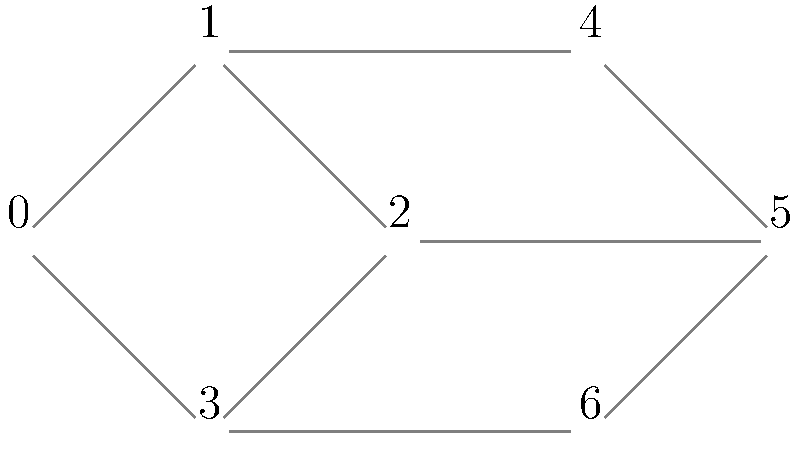As a university student helping with household repairs, you're asked to optimize the wiring layout for a home electrical system. The diagram represents different rooms and possible wiring connections. What is the minimum number of wiring connections needed to ensure all rooms are connected while minimizing the total wiring length? Assume each edge has a unit length. To optimize the wiring layout, we need to find the Minimum Spanning Tree (MST) of the given graph. Here's how we can solve this step-by-step:

1. Identify the graph:
   - 7 vertices (rooms): 0, 1, 2, 3, 4, 5, 6
   - 9 edges (possible connections)

2. We can use Kruskal's algorithm to find the MST:
   a) Sort all edges by weight (in this case, all edges have unit weight, so any order works)
   b) Start with an empty set of edges
   c) For each edge, add it to the set if it doesn't create a cycle

3. Apply Kruskal's algorithm:
   - Add edge (0,1)
   - Add edge (0,3)
   - Add edge (1,2)
   - Add edge (1,4)
   - Add edge (2,5)
   - Add edge (3,6)

4. After adding these 6 edges, all 7 vertices are connected without forming any cycles.

5. The resulting MST has 6 edges, which is the minimum number of connections needed to ensure all rooms are connected while minimizing the total wiring length.

This solution ensures that all rooms are connected with the minimum possible wiring, which is optimal for reducing material costs and potential electrical resistance in the system.
Answer: 6 connections 